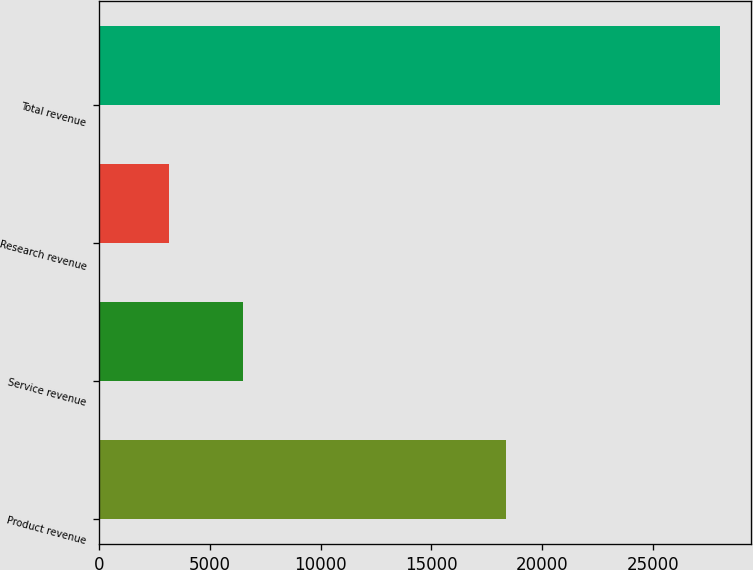<chart> <loc_0><loc_0><loc_500><loc_500><bar_chart><fcel>Product revenue<fcel>Service revenue<fcel>Research revenue<fcel>Total revenue<nl><fcel>18378<fcel>6496<fcel>3161<fcel>28035<nl></chart> 